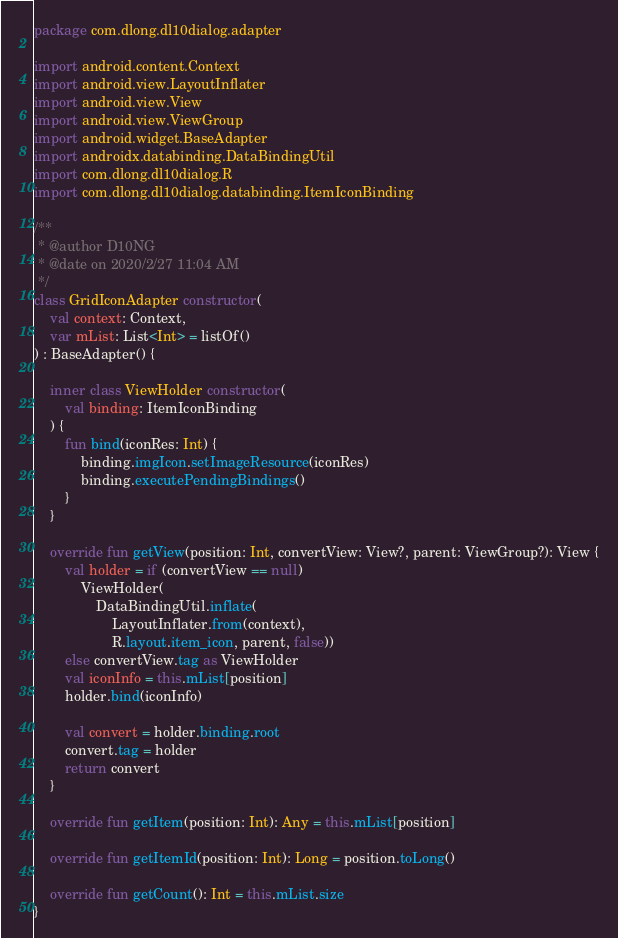Convert code to text. <code><loc_0><loc_0><loc_500><loc_500><_Kotlin_>package com.dlong.dl10dialog.adapter

import android.content.Context
import android.view.LayoutInflater
import android.view.View
import android.view.ViewGroup
import android.widget.BaseAdapter
import androidx.databinding.DataBindingUtil
import com.dlong.dl10dialog.R
import com.dlong.dl10dialog.databinding.ItemIconBinding

/**
 * @author D10NG
 * @date on 2020/2/27 11:04 AM
 */
class GridIconAdapter constructor(
    val context: Context,
    var mList: List<Int> = listOf()
) : BaseAdapter() {

    inner class ViewHolder constructor(
        val binding: ItemIconBinding
    ) {
        fun bind(iconRes: Int) {
            binding.imgIcon.setImageResource(iconRes)
            binding.executePendingBindings()
        }
    }

    override fun getView(position: Int, convertView: View?, parent: ViewGroup?): View {
        val holder = if (convertView == null)
            ViewHolder(
                DataBindingUtil.inflate(
                    LayoutInflater.from(context),
                    R.layout.item_icon, parent, false))
        else convertView.tag as ViewHolder
        val iconInfo = this.mList[position]
        holder.bind(iconInfo)

        val convert = holder.binding.root
        convert.tag = holder
        return convert
    }

    override fun getItem(position: Int): Any = this.mList[position]

    override fun getItemId(position: Int): Long = position.toLong()

    override fun getCount(): Int = this.mList.size
}</code> 